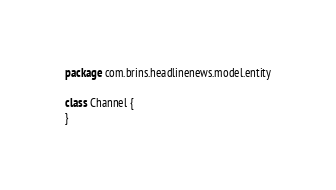Convert code to text. <code><loc_0><loc_0><loc_500><loc_500><_Kotlin_>package com.brins.headlinenews.model.entity

class Channel {
}</code> 